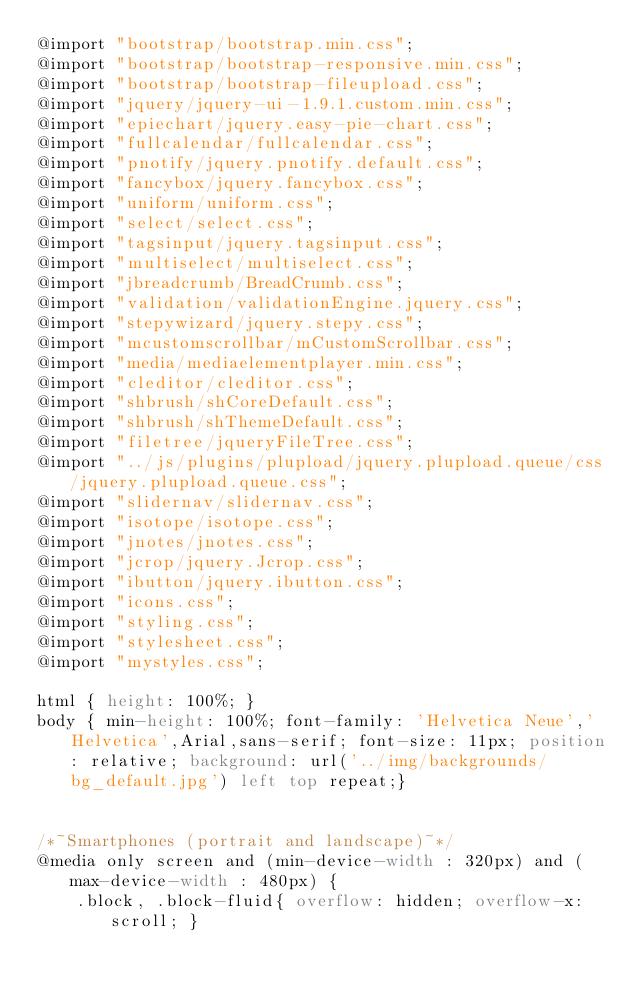<code> <loc_0><loc_0><loc_500><loc_500><_CSS_>@import "bootstrap/bootstrap.min.css";
@import "bootstrap/bootstrap-responsive.min.css";
@import "bootstrap/bootstrap-fileupload.css";
@import "jquery/jquery-ui-1.9.1.custom.min.css";
@import "epiechart/jquery.easy-pie-chart.css";
@import "fullcalendar/fullcalendar.css";
@import "pnotify/jquery.pnotify.default.css";
@import "fancybox/jquery.fancybox.css";
@import "uniform/uniform.css";
@import "select/select.css";
@import "tagsinput/jquery.tagsinput.css";
@import "multiselect/multiselect.css";
@import "jbreadcrumb/BreadCrumb.css";
@import "validation/validationEngine.jquery.css";
@import "stepywizard/jquery.stepy.css";
@import "mcustomscrollbar/mCustomScrollbar.css";
@import "media/mediaelementplayer.min.css";
@import "cleditor/cleditor.css";
@import "shbrush/shCoreDefault.css";
@import "shbrush/shThemeDefault.css";
@import "filetree/jqueryFileTree.css";
@import "../js/plugins/plupload/jquery.plupload.queue/css/jquery.plupload.queue.css";
@import "slidernav/slidernav.css";
@import "isotope/isotope.css";
@import "jnotes/jnotes.css";
@import "jcrop/jquery.Jcrop.css";
@import "ibutton/jquery.ibutton.css";
@import "icons.css";
@import "styling.css";
@import "stylesheet.css";
@import "mystyles.css";

html { height: 100%; }
body { min-height: 100%; font-family: 'Helvetica Neue','Helvetica',Arial,sans-serif; font-size: 11px; position: relative; background: url('../img/backgrounds/bg_default.jpg') left top repeat;}


/*~Smartphones (portrait and landscape)~*/
@media only screen and (min-device-width : 320px) and (max-device-width : 480px) {    
    .block, .block-fluid{ overflow: hidden; overflow-x: scroll; }</code> 